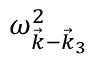<formula> <loc_0><loc_0><loc_500><loc_500>\omega _ { \vec { k } - \vec { k } _ { 3 } } ^ { 2 }</formula> 